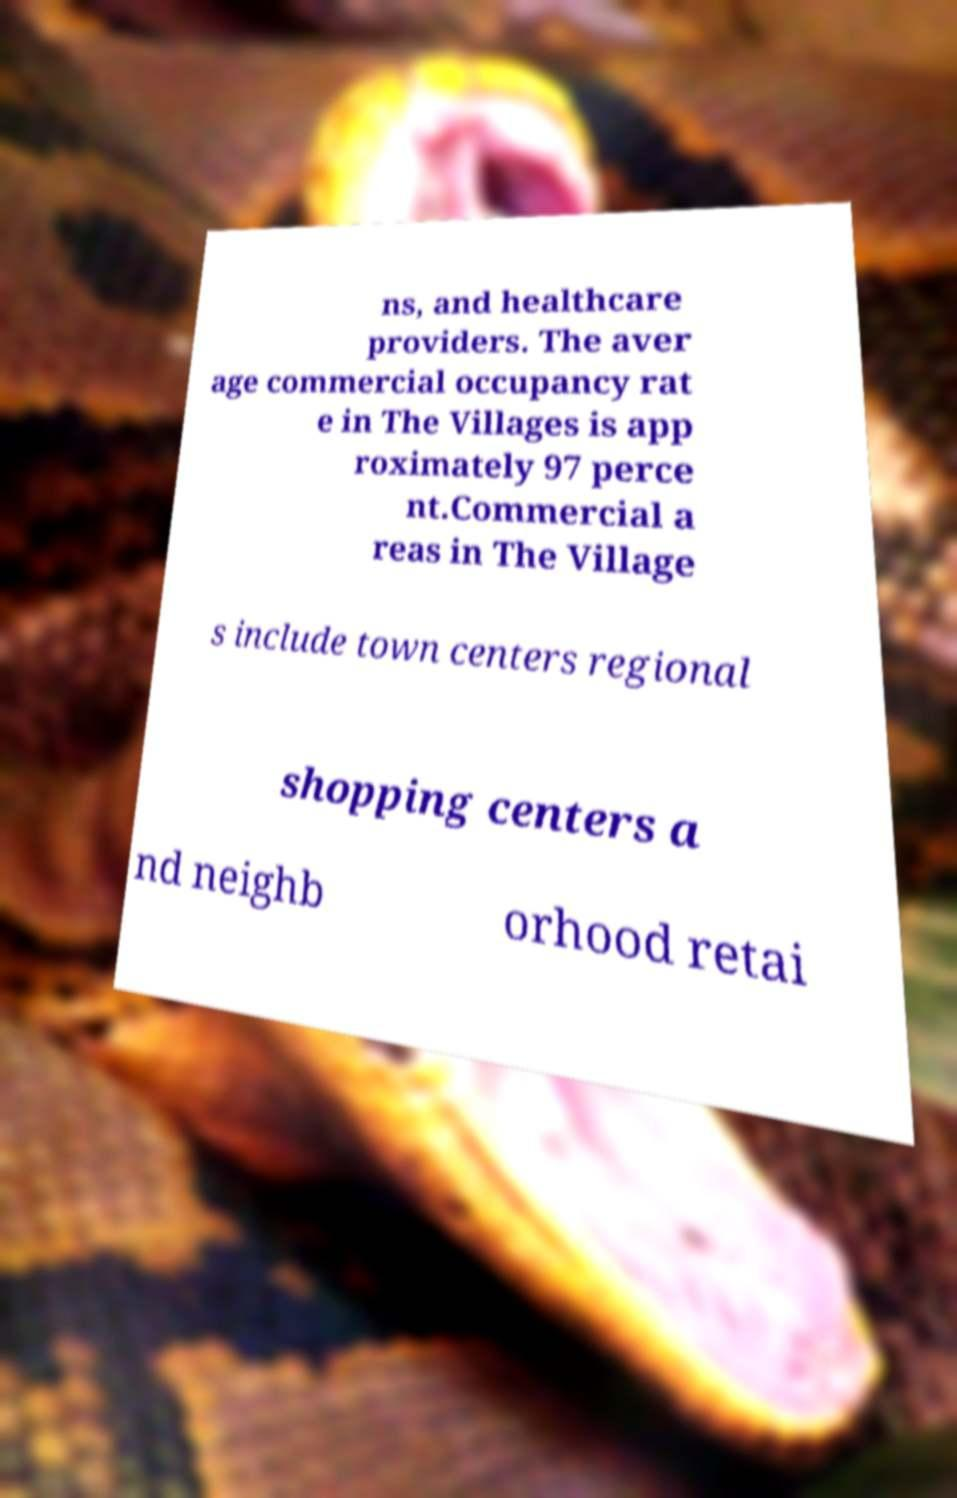Could you extract and type out the text from this image? ns, and healthcare providers. The aver age commercial occupancy rat e in The Villages is app roximately 97 perce nt.Commercial a reas in The Village s include town centers regional shopping centers a nd neighb orhood retai 